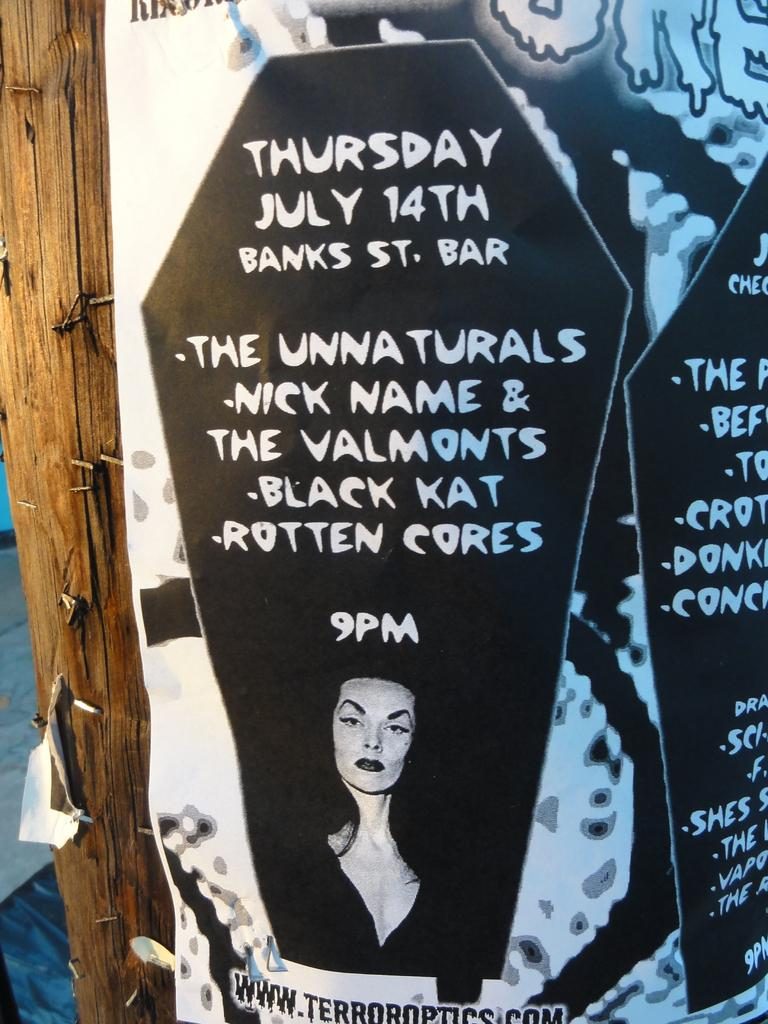What object made of wood can be seen in the image? There is a wooden pole in the image. What is attached to the wooden pole? There is a poster attached to the wooden pole. Can you describe the person in the image? There is a person in the image, but their appearance or actions are not specified. What is written or printed in the image? There is some text in the image. What is visible in the background of the image? The background of the image includes the floor. How many pigs are running across the nation in the image? There are no pigs or any reference to a nation in the image. What happens when the balloon bursts in the image? There is no balloon or any indication of a bursting event in the image. 